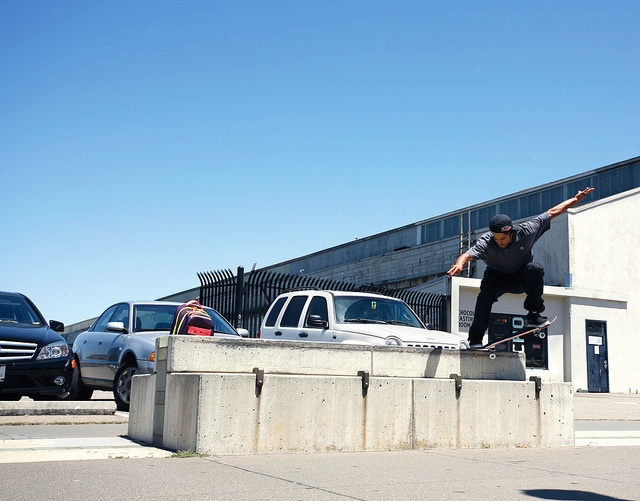Describe the objects in this image and their specific colors. I can see car in gray, white, black, navy, and darkgray tones, car in gray, black, blue, and navy tones, people in gray, black, maroon, and navy tones, car in gray, black, navy, and blue tones, and backpack in gray, black, salmon, ivory, and navy tones in this image. 